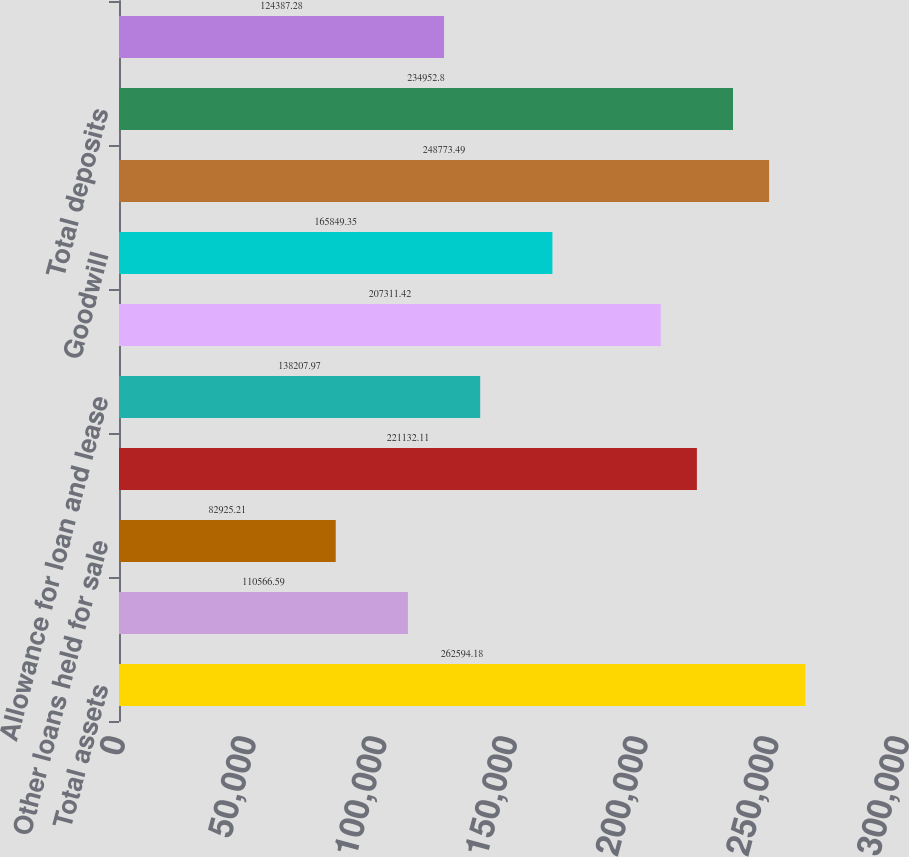<chart> <loc_0><loc_0><loc_500><loc_500><bar_chart><fcel>Total assets<fcel>Loans held for sale at fair<fcel>Other loans held for sale<fcel>Loans and leases<fcel>Allowance for loan and lease<fcel>Total securities<fcel>Goodwill<fcel>Total liabilities<fcel>Total deposits<fcel>Federal funds purchased and<nl><fcel>262594<fcel>110567<fcel>82925.2<fcel>221132<fcel>138208<fcel>207311<fcel>165849<fcel>248773<fcel>234953<fcel>124387<nl></chart> 